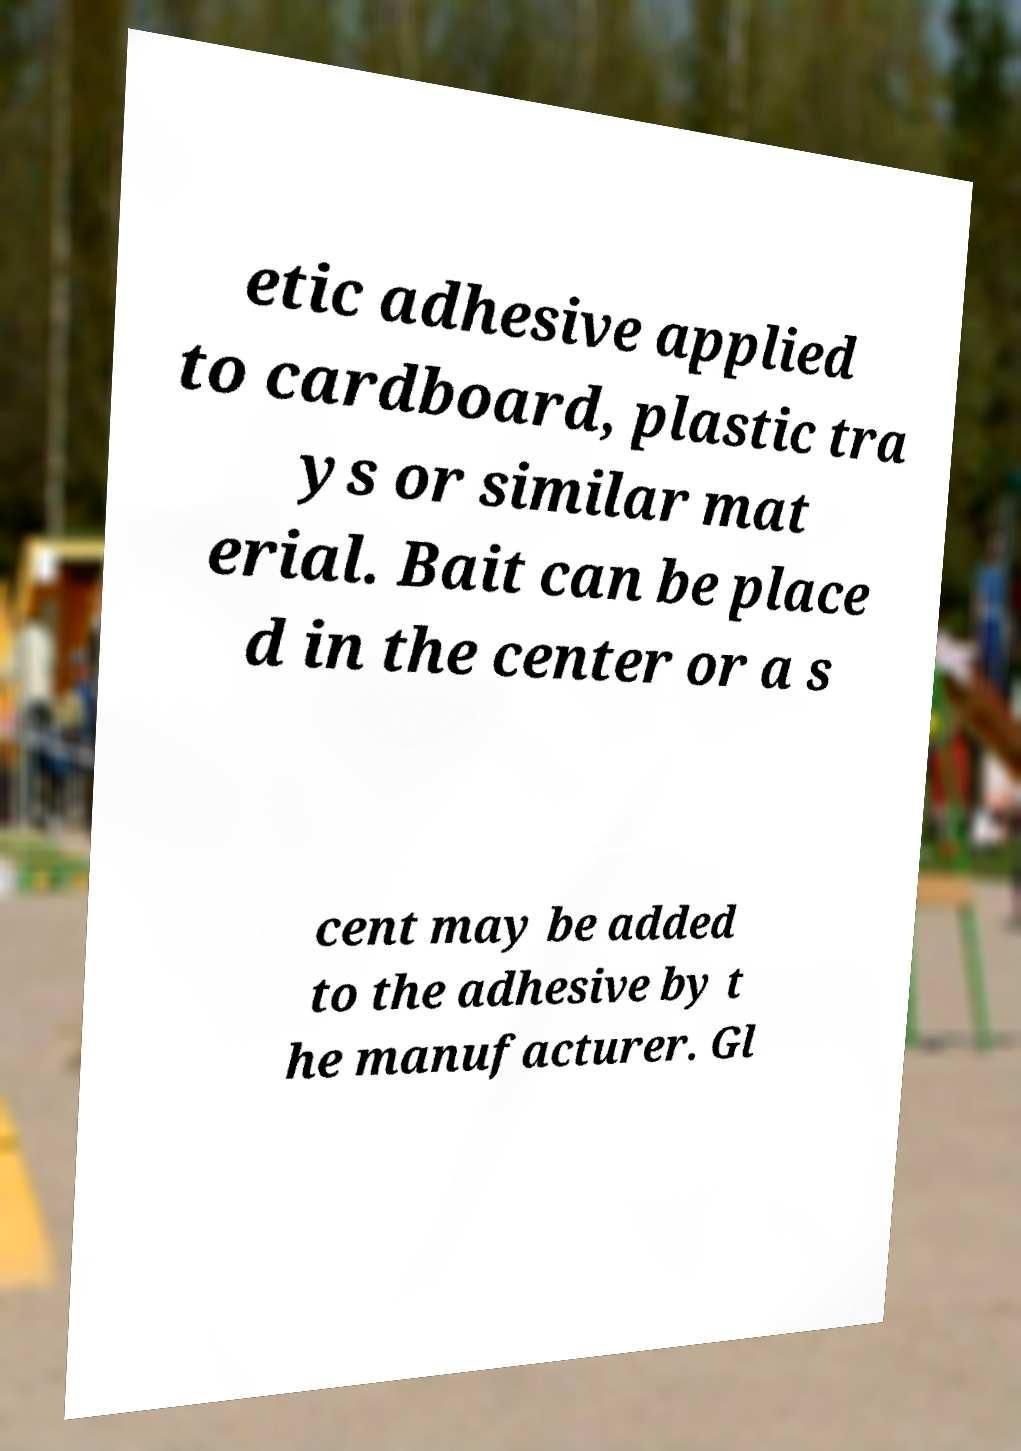What messages or text are displayed in this image? I need them in a readable, typed format. etic adhesive applied to cardboard, plastic tra ys or similar mat erial. Bait can be place d in the center or a s cent may be added to the adhesive by t he manufacturer. Gl 